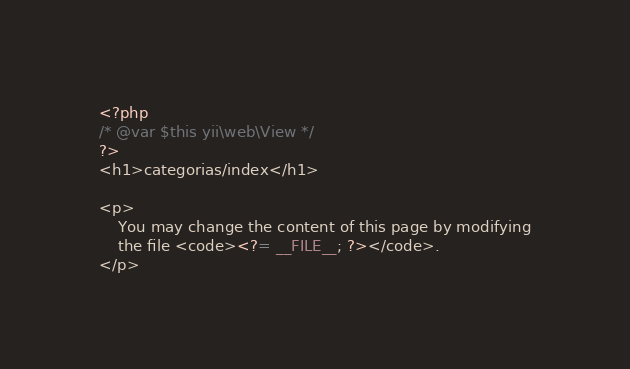<code> <loc_0><loc_0><loc_500><loc_500><_PHP_><?php
/* @var $this yii\web\View */
?>
<h1>categorias/index</h1>

<p>
    You may change the content of this page by modifying
    the file <code><?= __FILE__; ?></code>.
</p>
</code> 